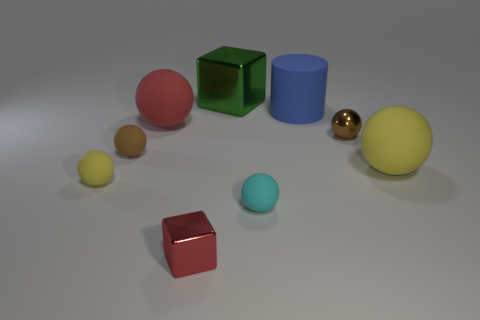Is there a matte ball of the same color as the big block?
Your response must be concise. No. Are there any tiny cubes?
Ensure brevity in your answer.  Yes. There is a matte thing behind the red rubber ball; is its size the same as the small yellow ball?
Ensure brevity in your answer.  No. Is the number of large green metal cubes less than the number of tiny purple metal things?
Make the answer very short. No. The red thing in front of the matte sphere in front of the rubber object that is to the left of the small brown matte thing is what shape?
Your response must be concise. Cube. Are there any blue things that have the same material as the small yellow object?
Your answer should be compact. Yes. There is a matte ball that is in front of the small yellow ball; is it the same color as the big ball on the right side of the red cube?
Give a very brief answer. No. Are there fewer large yellow objects that are behind the large red sphere than small objects?
Your answer should be very brief. Yes. What number of things are large red rubber spheres or small brown things on the left side of the tiny red cube?
Your response must be concise. 2. There is a sphere that is the same material as the small cube; what color is it?
Provide a short and direct response. Brown. 